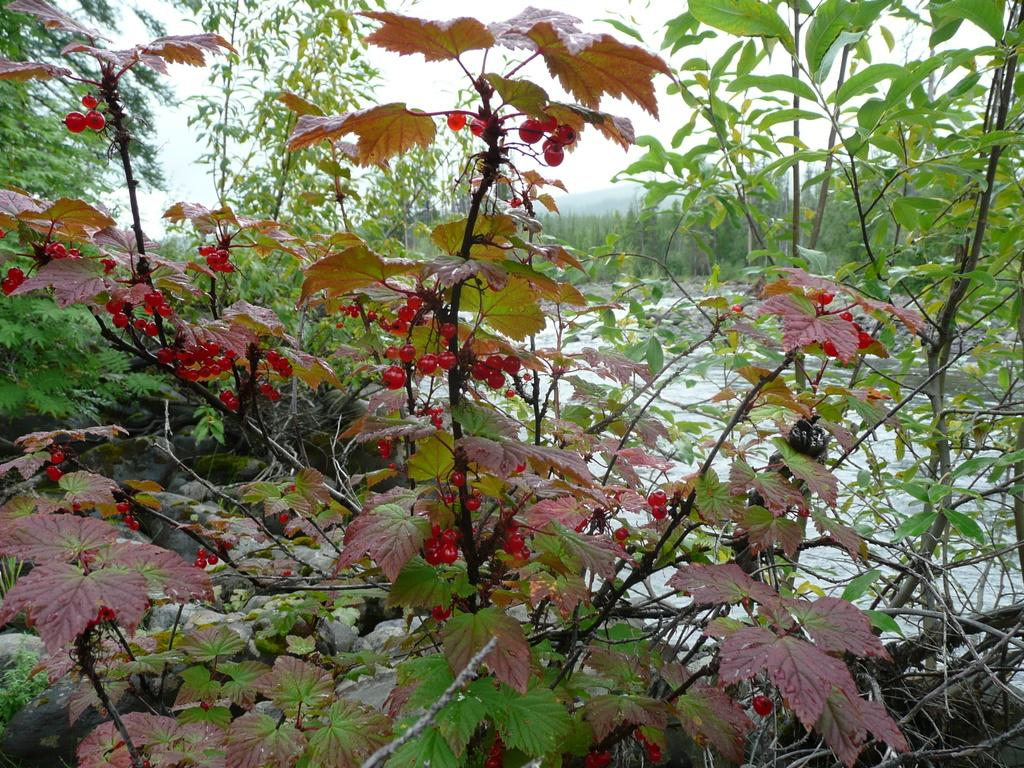What celestial bodies are depicted in the image? There are planets in the image. What type of fruit can be seen in the image? There are red currant fruits in the image. What can be seen in the background of the image? There is water, trees, a hill, and the sky visible in the background of the image. What type of coach can be seen in the image? There is no coach present in the image. How many bushes are visible in the image? There is no mention of bushes in the provided facts, so we cannot determine their presence or quantity in the image. 